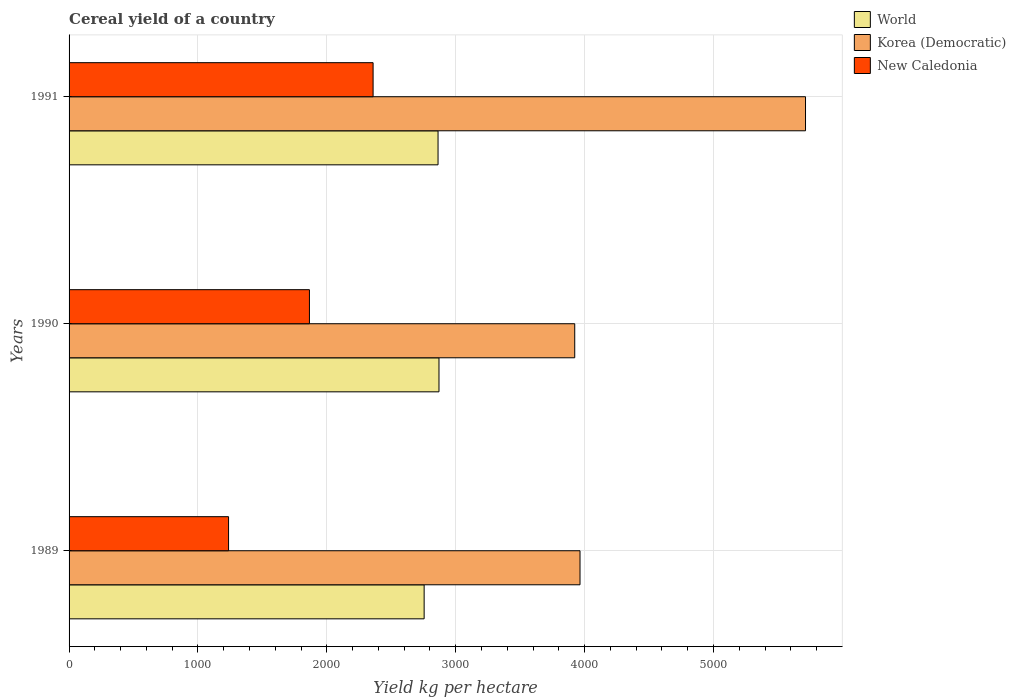How many different coloured bars are there?
Your response must be concise. 3. How many groups of bars are there?
Give a very brief answer. 3. How many bars are there on the 2nd tick from the top?
Offer a terse response. 3. What is the total cereal yield in New Caledonia in 1991?
Provide a succinct answer. 2358.97. Across all years, what is the maximum total cereal yield in New Caledonia?
Make the answer very short. 2358.97. Across all years, what is the minimum total cereal yield in Korea (Democratic)?
Make the answer very short. 3923.44. In which year was the total cereal yield in New Caledonia minimum?
Your answer should be very brief. 1989. What is the total total cereal yield in New Caledonia in the graph?
Ensure brevity in your answer.  5461.54. What is the difference between the total cereal yield in World in 1990 and that in 1991?
Make the answer very short. 7.25. What is the difference between the total cereal yield in World in 1991 and the total cereal yield in Korea (Democratic) in 1989?
Provide a short and direct response. -1101.52. What is the average total cereal yield in World per year?
Offer a very short reply. 2829.37. In the year 1991, what is the difference between the total cereal yield in Korea (Democratic) and total cereal yield in New Caledonia?
Your answer should be very brief. 3355.13. What is the ratio of the total cereal yield in World in 1990 to that in 1991?
Ensure brevity in your answer.  1. Is the total cereal yield in New Caledonia in 1989 less than that in 1991?
Provide a short and direct response. Yes. What is the difference between the highest and the second highest total cereal yield in New Caledonia?
Your response must be concise. 493.91. What is the difference between the highest and the lowest total cereal yield in New Caledonia?
Make the answer very short. 1121.47. In how many years, is the total cereal yield in Korea (Democratic) greater than the average total cereal yield in Korea (Democratic) taken over all years?
Your answer should be compact. 1. What does the 1st bar from the top in 1989 represents?
Provide a short and direct response. New Caledonia. What does the 2nd bar from the bottom in 1991 represents?
Ensure brevity in your answer.  Korea (Democratic). Are all the bars in the graph horizontal?
Make the answer very short. Yes. Does the graph contain grids?
Provide a short and direct response. Yes. Where does the legend appear in the graph?
Your answer should be very brief. Top right. How many legend labels are there?
Offer a terse response. 3. What is the title of the graph?
Your answer should be very brief. Cereal yield of a country. Does "Samoa" appear as one of the legend labels in the graph?
Ensure brevity in your answer.  No. What is the label or title of the X-axis?
Provide a short and direct response. Yield kg per hectare. What is the label or title of the Y-axis?
Ensure brevity in your answer.  Years. What is the Yield kg per hectare of World in 1989?
Offer a terse response. 2755. What is the Yield kg per hectare of Korea (Democratic) in 1989?
Keep it short and to the point. 3964.44. What is the Yield kg per hectare in New Caledonia in 1989?
Provide a succinct answer. 1237.5. What is the Yield kg per hectare of World in 1990?
Your answer should be very brief. 2870.18. What is the Yield kg per hectare in Korea (Democratic) in 1990?
Keep it short and to the point. 3923.44. What is the Yield kg per hectare of New Caledonia in 1990?
Offer a very short reply. 1865.07. What is the Yield kg per hectare in World in 1991?
Make the answer very short. 2862.92. What is the Yield kg per hectare in Korea (Democratic) in 1991?
Offer a very short reply. 5714.1. What is the Yield kg per hectare in New Caledonia in 1991?
Offer a terse response. 2358.97. Across all years, what is the maximum Yield kg per hectare of World?
Keep it short and to the point. 2870.18. Across all years, what is the maximum Yield kg per hectare of Korea (Democratic)?
Your answer should be compact. 5714.1. Across all years, what is the maximum Yield kg per hectare in New Caledonia?
Your answer should be compact. 2358.97. Across all years, what is the minimum Yield kg per hectare of World?
Provide a short and direct response. 2755. Across all years, what is the minimum Yield kg per hectare of Korea (Democratic)?
Make the answer very short. 3923.44. Across all years, what is the minimum Yield kg per hectare in New Caledonia?
Your answer should be very brief. 1237.5. What is the total Yield kg per hectare of World in the graph?
Ensure brevity in your answer.  8488.1. What is the total Yield kg per hectare of Korea (Democratic) in the graph?
Your answer should be very brief. 1.36e+04. What is the total Yield kg per hectare in New Caledonia in the graph?
Offer a terse response. 5461.54. What is the difference between the Yield kg per hectare of World in 1989 and that in 1990?
Offer a terse response. -115.18. What is the difference between the Yield kg per hectare in Korea (Democratic) in 1989 and that in 1990?
Ensure brevity in your answer.  41. What is the difference between the Yield kg per hectare of New Caledonia in 1989 and that in 1990?
Provide a short and direct response. -627.57. What is the difference between the Yield kg per hectare in World in 1989 and that in 1991?
Provide a short and direct response. -107.93. What is the difference between the Yield kg per hectare in Korea (Democratic) in 1989 and that in 1991?
Provide a succinct answer. -1749.66. What is the difference between the Yield kg per hectare of New Caledonia in 1989 and that in 1991?
Keep it short and to the point. -1121.47. What is the difference between the Yield kg per hectare in World in 1990 and that in 1991?
Provide a succinct answer. 7.25. What is the difference between the Yield kg per hectare in Korea (Democratic) in 1990 and that in 1991?
Make the answer very short. -1790.66. What is the difference between the Yield kg per hectare of New Caledonia in 1990 and that in 1991?
Provide a short and direct response. -493.91. What is the difference between the Yield kg per hectare in World in 1989 and the Yield kg per hectare in Korea (Democratic) in 1990?
Your answer should be compact. -1168.44. What is the difference between the Yield kg per hectare of World in 1989 and the Yield kg per hectare of New Caledonia in 1990?
Give a very brief answer. 889.93. What is the difference between the Yield kg per hectare of Korea (Democratic) in 1989 and the Yield kg per hectare of New Caledonia in 1990?
Your response must be concise. 2099.37. What is the difference between the Yield kg per hectare of World in 1989 and the Yield kg per hectare of Korea (Democratic) in 1991?
Provide a short and direct response. -2959.11. What is the difference between the Yield kg per hectare in World in 1989 and the Yield kg per hectare in New Caledonia in 1991?
Ensure brevity in your answer.  396.02. What is the difference between the Yield kg per hectare in Korea (Democratic) in 1989 and the Yield kg per hectare in New Caledonia in 1991?
Provide a succinct answer. 1605.46. What is the difference between the Yield kg per hectare of World in 1990 and the Yield kg per hectare of Korea (Democratic) in 1991?
Make the answer very short. -2843.93. What is the difference between the Yield kg per hectare of World in 1990 and the Yield kg per hectare of New Caledonia in 1991?
Your response must be concise. 511.2. What is the difference between the Yield kg per hectare of Korea (Democratic) in 1990 and the Yield kg per hectare of New Caledonia in 1991?
Make the answer very short. 1564.47. What is the average Yield kg per hectare of World per year?
Offer a very short reply. 2829.37. What is the average Yield kg per hectare of Korea (Democratic) per year?
Provide a succinct answer. 4533.99. What is the average Yield kg per hectare in New Caledonia per year?
Keep it short and to the point. 1820.51. In the year 1989, what is the difference between the Yield kg per hectare of World and Yield kg per hectare of Korea (Democratic)?
Your answer should be very brief. -1209.44. In the year 1989, what is the difference between the Yield kg per hectare in World and Yield kg per hectare in New Caledonia?
Keep it short and to the point. 1517.5. In the year 1989, what is the difference between the Yield kg per hectare in Korea (Democratic) and Yield kg per hectare in New Caledonia?
Provide a short and direct response. 2726.94. In the year 1990, what is the difference between the Yield kg per hectare of World and Yield kg per hectare of Korea (Democratic)?
Your answer should be very brief. -1053.26. In the year 1990, what is the difference between the Yield kg per hectare of World and Yield kg per hectare of New Caledonia?
Offer a terse response. 1005.11. In the year 1990, what is the difference between the Yield kg per hectare of Korea (Democratic) and Yield kg per hectare of New Caledonia?
Offer a terse response. 2058.37. In the year 1991, what is the difference between the Yield kg per hectare in World and Yield kg per hectare in Korea (Democratic)?
Your response must be concise. -2851.18. In the year 1991, what is the difference between the Yield kg per hectare of World and Yield kg per hectare of New Caledonia?
Keep it short and to the point. 503.95. In the year 1991, what is the difference between the Yield kg per hectare in Korea (Democratic) and Yield kg per hectare in New Caledonia?
Make the answer very short. 3355.13. What is the ratio of the Yield kg per hectare of World in 1989 to that in 1990?
Keep it short and to the point. 0.96. What is the ratio of the Yield kg per hectare in Korea (Democratic) in 1989 to that in 1990?
Your answer should be very brief. 1.01. What is the ratio of the Yield kg per hectare in New Caledonia in 1989 to that in 1990?
Your answer should be very brief. 0.66. What is the ratio of the Yield kg per hectare in World in 1989 to that in 1991?
Offer a very short reply. 0.96. What is the ratio of the Yield kg per hectare of Korea (Democratic) in 1989 to that in 1991?
Provide a short and direct response. 0.69. What is the ratio of the Yield kg per hectare of New Caledonia in 1989 to that in 1991?
Keep it short and to the point. 0.52. What is the ratio of the Yield kg per hectare in Korea (Democratic) in 1990 to that in 1991?
Keep it short and to the point. 0.69. What is the ratio of the Yield kg per hectare in New Caledonia in 1990 to that in 1991?
Provide a succinct answer. 0.79. What is the difference between the highest and the second highest Yield kg per hectare of World?
Offer a terse response. 7.25. What is the difference between the highest and the second highest Yield kg per hectare in Korea (Democratic)?
Give a very brief answer. 1749.66. What is the difference between the highest and the second highest Yield kg per hectare of New Caledonia?
Provide a short and direct response. 493.91. What is the difference between the highest and the lowest Yield kg per hectare in World?
Offer a terse response. 115.18. What is the difference between the highest and the lowest Yield kg per hectare in Korea (Democratic)?
Your response must be concise. 1790.66. What is the difference between the highest and the lowest Yield kg per hectare of New Caledonia?
Keep it short and to the point. 1121.47. 